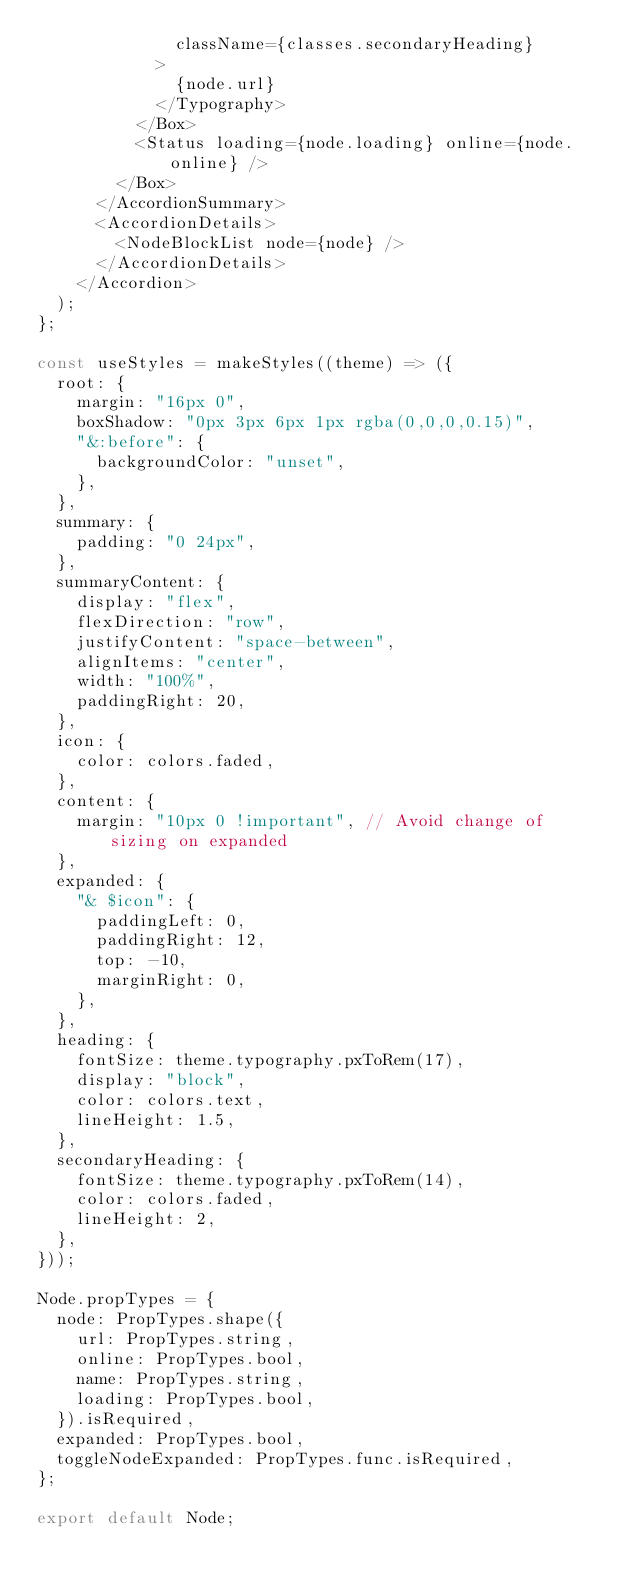Convert code to text. <code><loc_0><loc_0><loc_500><loc_500><_JavaScript_>              className={classes.secondaryHeading}
            >
              {node.url}
            </Typography>
          </Box>
          <Status loading={node.loading} online={node.online} />
        </Box>
      </AccordionSummary>
      <AccordionDetails>
        <NodeBlockList node={node} />
      </AccordionDetails>
    </Accordion>
  );
};

const useStyles = makeStyles((theme) => ({
  root: {
    margin: "16px 0",
    boxShadow: "0px 3px 6px 1px rgba(0,0,0,0.15)",
    "&:before": {
      backgroundColor: "unset",
    },
  },
  summary: {
    padding: "0 24px",
  },
  summaryContent: {
    display: "flex",
    flexDirection: "row",
    justifyContent: "space-between",
    alignItems: "center",
    width: "100%",
    paddingRight: 20,
  },
  icon: {
    color: colors.faded,
  },
  content: {
    margin: "10px 0 !important", // Avoid change of sizing on expanded
  },
  expanded: {
    "& $icon": {
      paddingLeft: 0,
      paddingRight: 12,
      top: -10,
      marginRight: 0,
    },
  },
  heading: {
    fontSize: theme.typography.pxToRem(17),
    display: "block",
    color: colors.text,
    lineHeight: 1.5,
  },
  secondaryHeading: {
    fontSize: theme.typography.pxToRem(14),
    color: colors.faded,
    lineHeight: 2,
  },
}));

Node.propTypes = {
  node: PropTypes.shape({
    url: PropTypes.string,
    online: PropTypes.bool,
    name: PropTypes.string,
    loading: PropTypes.bool,
  }).isRequired,
  expanded: PropTypes.bool,
  toggleNodeExpanded: PropTypes.func.isRequired,
};

export default Node;
</code> 